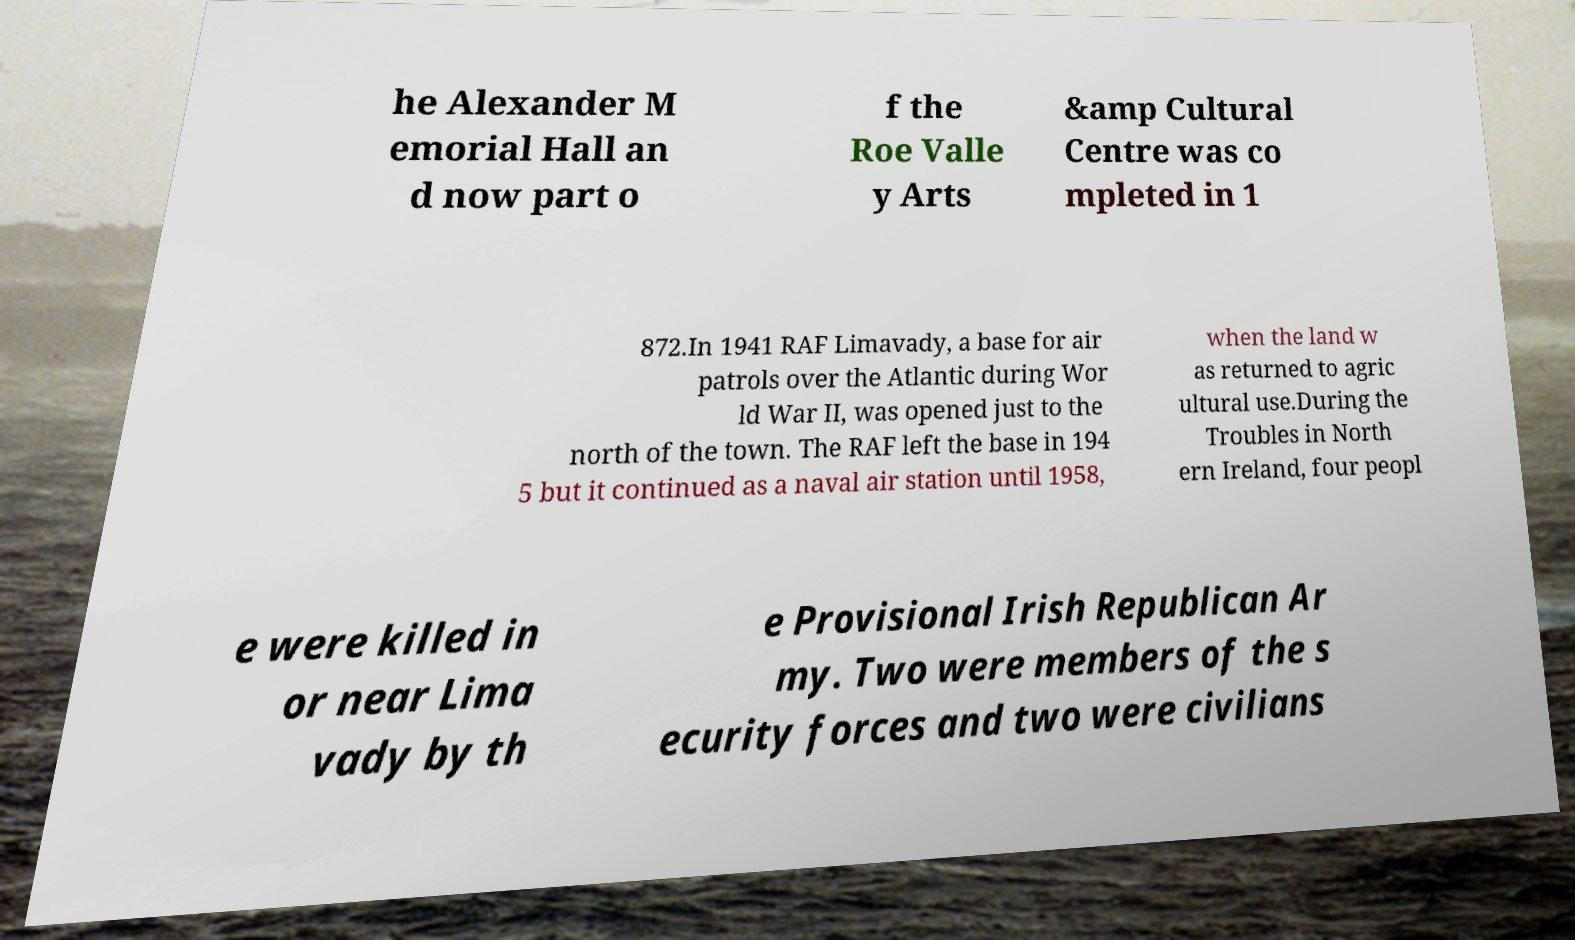Could you assist in decoding the text presented in this image and type it out clearly? he Alexander M emorial Hall an d now part o f the Roe Valle y Arts &amp Cultural Centre was co mpleted in 1 872.In 1941 RAF Limavady, a base for air patrols over the Atlantic during Wor ld War II, was opened just to the north of the town. The RAF left the base in 194 5 but it continued as a naval air station until 1958, when the land w as returned to agric ultural use.During the Troubles in North ern Ireland, four peopl e were killed in or near Lima vady by th e Provisional Irish Republican Ar my. Two were members of the s ecurity forces and two were civilians 